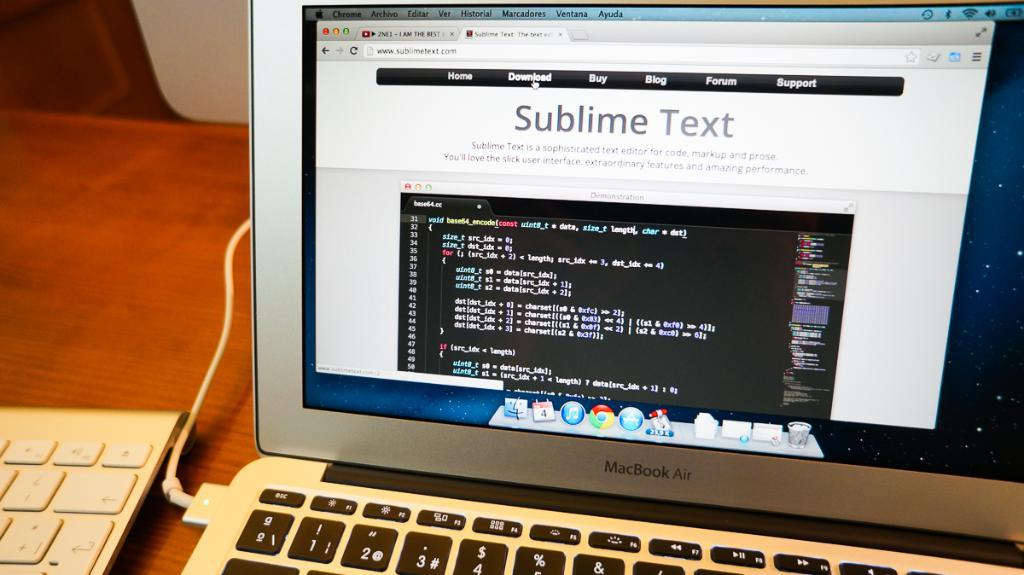<image>
Render a clear and concise summary of the photo. A computer monitor sitting on a desk displaying Sublime Text page. 